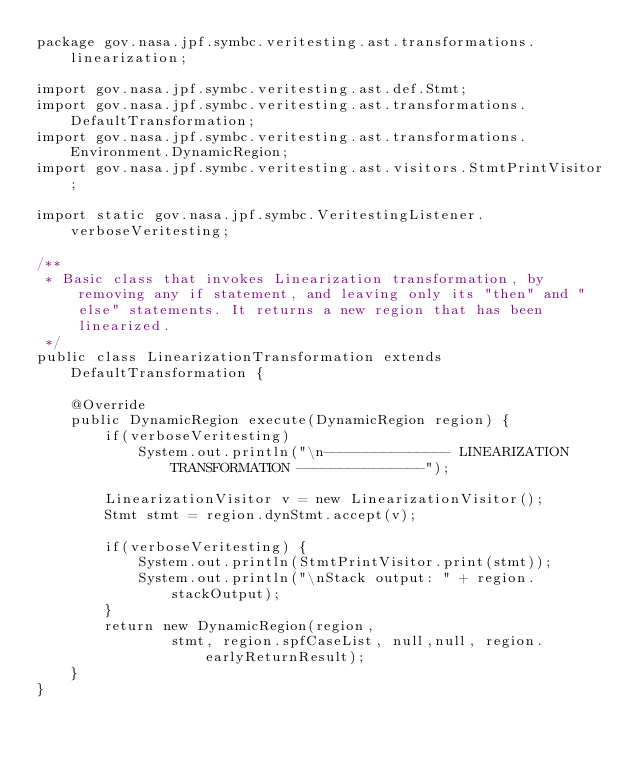Convert code to text. <code><loc_0><loc_0><loc_500><loc_500><_Java_>package gov.nasa.jpf.symbc.veritesting.ast.transformations.linearization;

import gov.nasa.jpf.symbc.veritesting.ast.def.Stmt;
import gov.nasa.jpf.symbc.veritesting.ast.transformations.DefaultTransformation;
import gov.nasa.jpf.symbc.veritesting.ast.transformations.Environment.DynamicRegion;
import gov.nasa.jpf.symbc.veritesting.ast.visitors.StmtPrintVisitor;

import static gov.nasa.jpf.symbc.VeritestingListener.verboseVeritesting;

/**
 * Basic class that invokes Linearization transformation, by removing any if statement, and leaving only its "then" and "else" statements. It returns a new region that has been linearized.
 */
public class LinearizationTransformation extends DefaultTransformation {

    @Override
    public DynamicRegion execute(DynamicRegion region) {
        if(verboseVeritesting)
            System.out.println("\n--------------- LINEARIZATION TRANSFORMATION ---------------");

        LinearizationVisitor v = new LinearizationVisitor();
        Stmt stmt = region.dynStmt.accept(v);

        if(verboseVeritesting) {
            System.out.println(StmtPrintVisitor.print(stmt));
            System.out.println("\nStack output: " + region.stackOutput);
        }
        return new DynamicRegion(region,
                stmt, region.spfCaseList, null,null, region.earlyReturnResult);
    }
}
</code> 